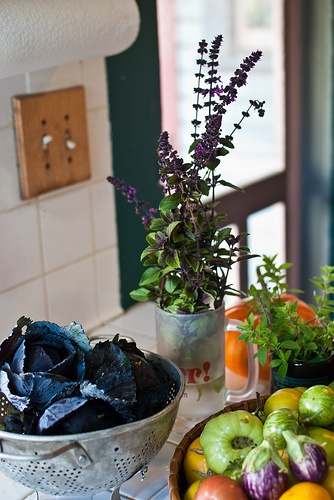<image>
Is there a plant on the pot? No. The plant is not positioned on the pot. They may be near each other, but the plant is not supported by or resting on top of the pot. Is the tomato in front of the cup? No. The tomato is not in front of the cup. The spatial positioning shows a different relationship between these objects. 